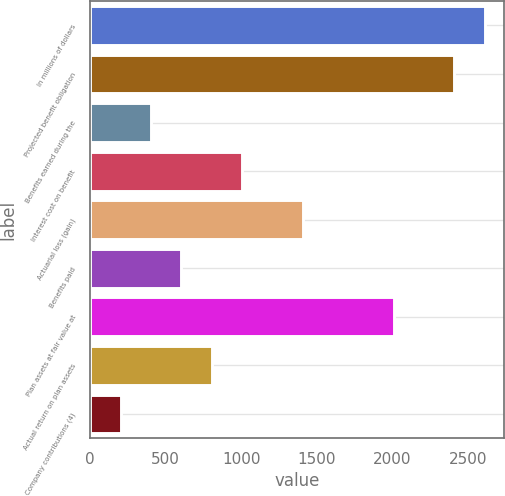<chart> <loc_0><loc_0><loc_500><loc_500><bar_chart><fcel>In millions of dollars<fcel>Projected benefit obligation<fcel>Benefits earned during the<fcel>Interest cost on benefit<fcel>Actuarial loss (gain)<fcel>Benefits paid<fcel>Plan assets at fair value at<fcel>Actual return on plan assets<fcel>Company contributions (4)<nl><fcel>2608.8<fcel>2408.2<fcel>402.2<fcel>1004<fcel>1405.2<fcel>602.8<fcel>2007<fcel>803.4<fcel>201.6<nl></chart> 